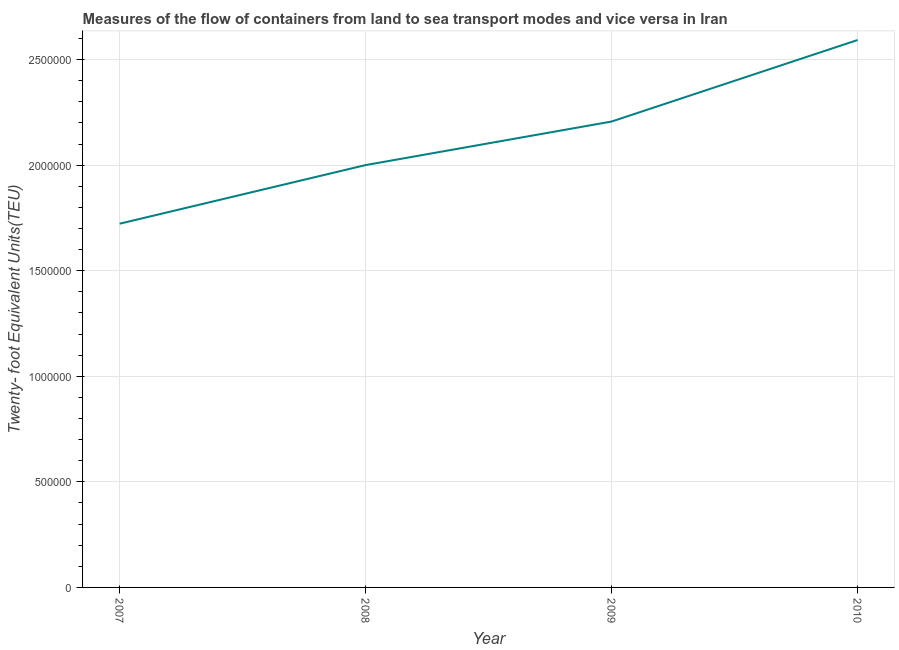What is the container port traffic in 2008?
Provide a succinct answer. 2.00e+06. Across all years, what is the maximum container port traffic?
Provide a short and direct response. 2.59e+06. Across all years, what is the minimum container port traffic?
Offer a very short reply. 1.72e+06. In which year was the container port traffic maximum?
Keep it short and to the point. 2010. In which year was the container port traffic minimum?
Offer a very short reply. 2007. What is the sum of the container port traffic?
Provide a succinct answer. 8.52e+06. What is the difference between the container port traffic in 2007 and 2009?
Make the answer very short. -4.84e+05. What is the average container port traffic per year?
Offer a very short reply. 2.13e+06. What is the median container port traffic?
Offer a terse response. 2.10e+06. Do a majority of the years between 2009 and 2008 (inclusive) have container port traffic greater than 2300000 TEU?
Your answer should be very brief. No. What is the ratio of the container port traffic in 2007 to that in 2009?
Your answer should be very brief. 0.78. Is the container port traffic in 2008 less than that in 2009?
Your answer should be compact. Yes. Is the difference between the container port traffic in 2009 and 2010 greater than the difference between any two years?
Your response must be concise. No. What is the difference between the highest and the second highest container port traffic?
Keep it short and to the point. 3.86e+05. Is the sum of the container port traffic in 2007 and 2009 greater than the maximum container port traffic across all years?
Make the answer very short. Yes. What is the difference between the highest and the lowest container port traffic?
Provide a short and direct response. 8.70e+05. In how many years, is the container port traffic greater than the average container port traffic taken over all years?
Give a very brief answer. 2. How many years are there in the graph?
Keep it short and to the point. 4. What is the title of the graph?
Your answer should be compact. Measures of the flow of containers from land to sea transport modes and vice versa in Iran. What is the label or title of the Y-axis?
Your response must be concise. Twenty- foot Equivalent Units(TEU). What is the Twenty- foot Equivalent Units(TEU) in 2007?
Your answer should be compact. 1.72e+06. What is the Twenty- foot Equivalent Units(TEU) in 2008?
Offer a terse response. 2.00e+06. What is the Twenty- foot Equivalent Units(TEU) of 2009?
Give a very brief answer. 2.21e+06. What is the Twenty- foot Equivalent Units(TEU) in 2010?
Provide a short and direct response. 2.59e+06. What is the difference between the Twenty- foot Equivalent Units(TEU) in 2007 and 2008?
Keep it short and to the point. -2.78e+05. What is the difference between the Twenty- foot Equivalent Units(TEU) in 2007 and 2009?
Provide a succinct answer. -4.84e+05. What is the difference between the Twenty- foot Equivalent Units(TEU) in 2007 and 2010?
Ensure brevity in your answer.  -8.70e+05. What is the difference between the Twenty- foot Equivalent Units(TEU) in 2008 and 2009?
Your response must be concise. -2.06e+05. What is the difference between the Twenty- foot Equivalent Units(TEU) in 2008 and 2010?
Provide a short and direct response. -5.92e+05. What is the difference between the Twenty- foot Equivalent Units(TEU) in 2009 and 2010?
Your answer should be very brief. -3.86e+05. What is the ratio of the Twenty- foot Equivalent Units(TEU) in 2007 to that in 2008?
Keep it short and to the point. 0.86. What is the ratio of the Twenty- foot Equivalent Units(TEU) in 2007 to that in 2009?
Offer a terse response. 0.78. What is the ratio of the Twenty- foot Equivalent Units(TEU) in 2007 to that in 2010?
Give a very brief answer. 0.66. What is the ratio of the Twenty- foot Equivalent Units(TEU) in 2008 to that in 2009?
Keep it short and to the point. 0.91. What is the ratio of the Twenty- foot Equivalent Units(TEU) in 2008 to that in 2010?
Offer a very short reply. 0.77. What is the ratio of the Twenty- foot Equivalent Units(TEU) in 2009 to that in 2010?
Offer a very short reply. 0.85. 